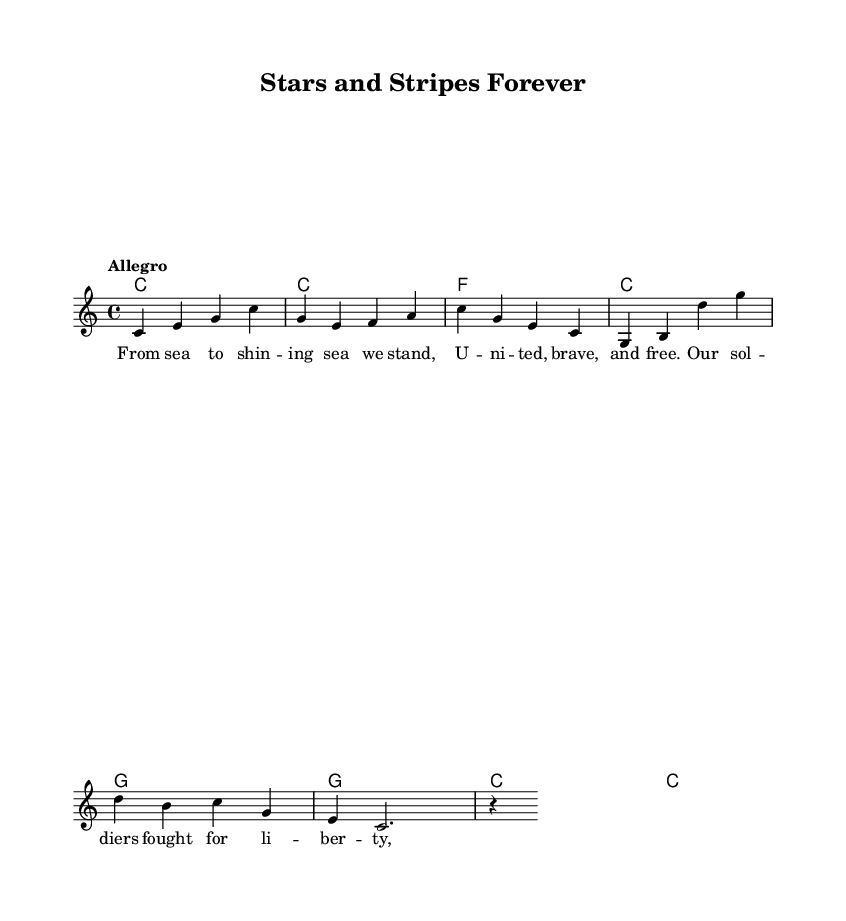What is the key signature of this music? The key signature is indicated to be C major. This is determined by examining the opening of the score where the key is explicitly stated as "c \major" with no sharps or flats visible on the staff.
Answer: C major What is the time signature of the piece? The time signature is stated as 4/4 in the score, which is evident at the beginning of the music where it specifies the rhythmic structure of four beats per measure.
Answer: 4/4 What is the tempo marking for this piece? The tempo marking provided is "Allegro," which implies a fast and lively pace. This is found at the top of the score near the beginning, directly above the clef and time signature.
Answer: Allegro How many measures are in the melody section? The melody section comprises eight measures, which can be counted by examining the divisions in the melody and harmonies provided in the score. Each line contains four measures, totaling to eight measures in the entire melody.
Answer: Eight What lyrics are associated with the melody? The lyrics provided correspond with the melody and start with "From sea to shining sea we stand." This is found in the verse section of the score where the lyrics are aligned with the musical notes in the melody.
Answer: From sea to shining sea we stand What is the final chord of the harmony section? The final chord of the harmony section is a C chord, as it concludes with "c" in the harmonies indicated at the end of the chord progression.
Answer: C 